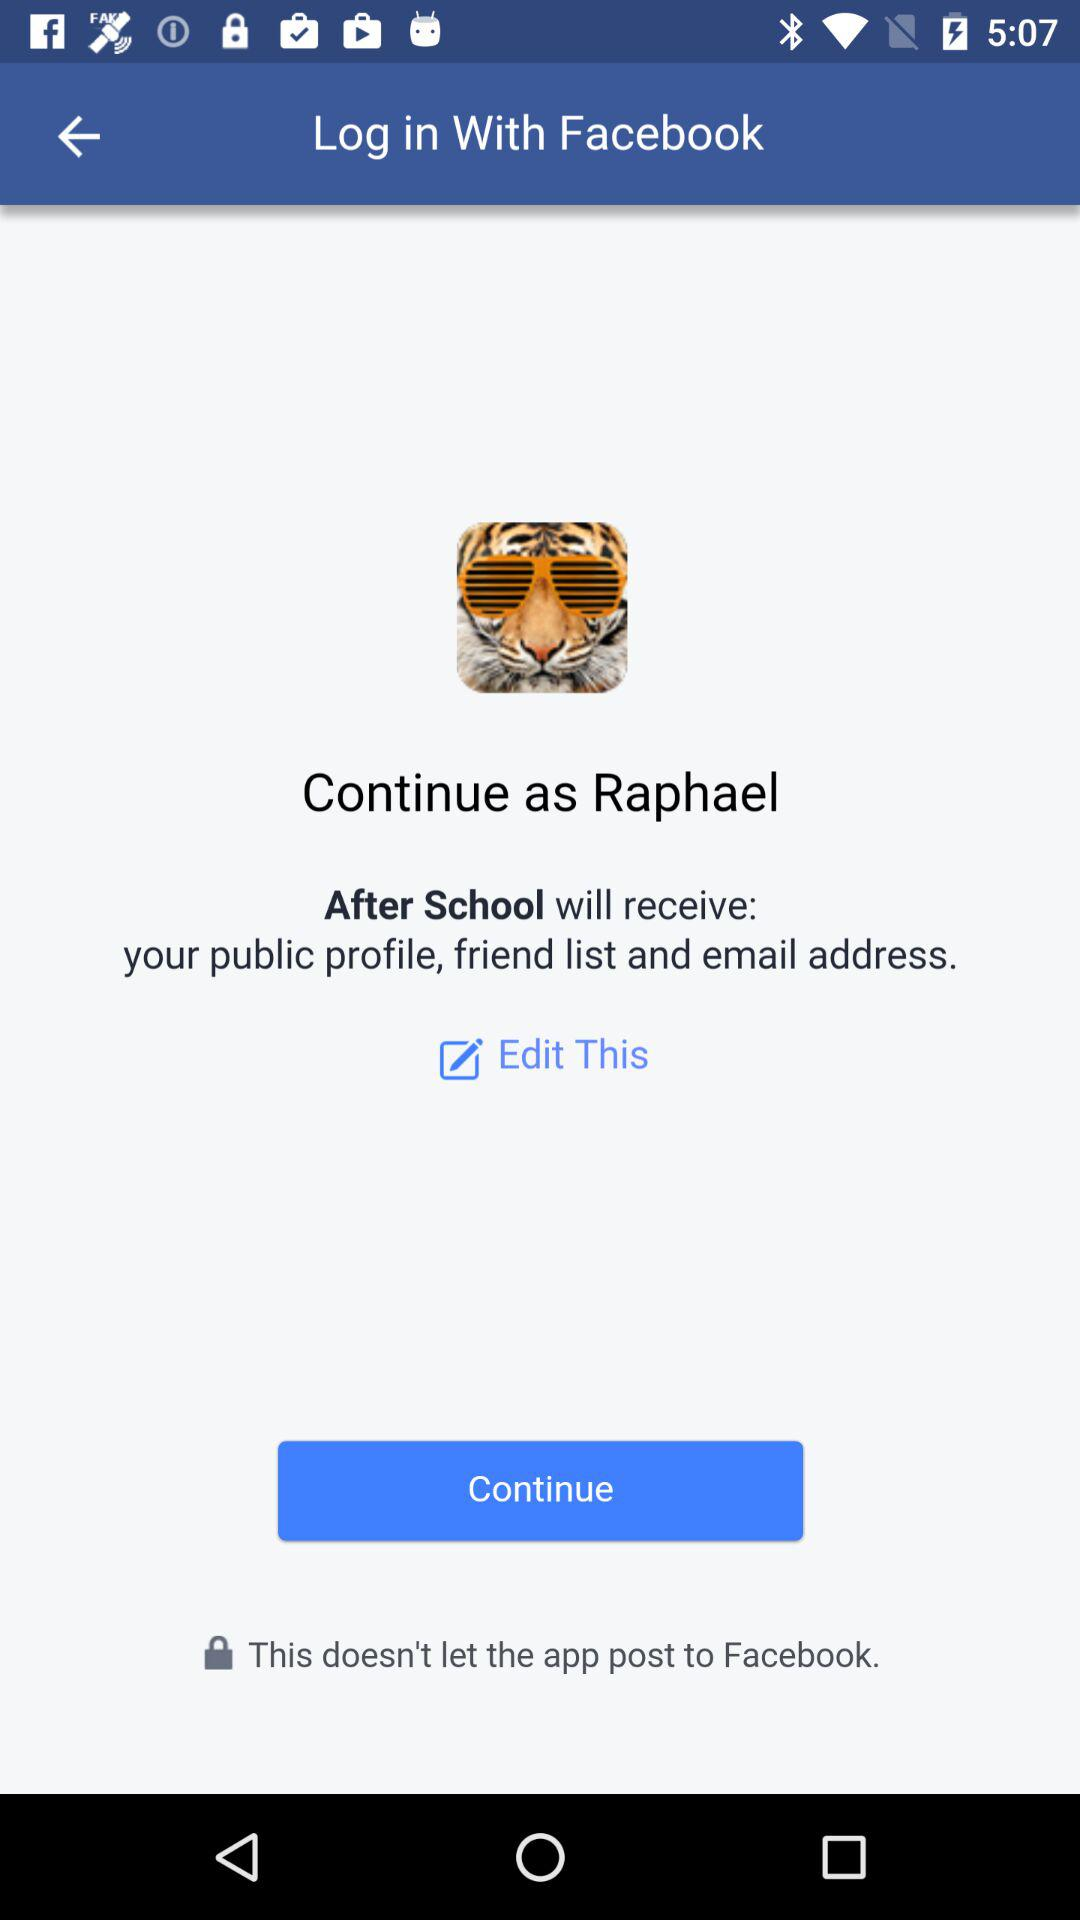What is the username? The username is Raphael. 